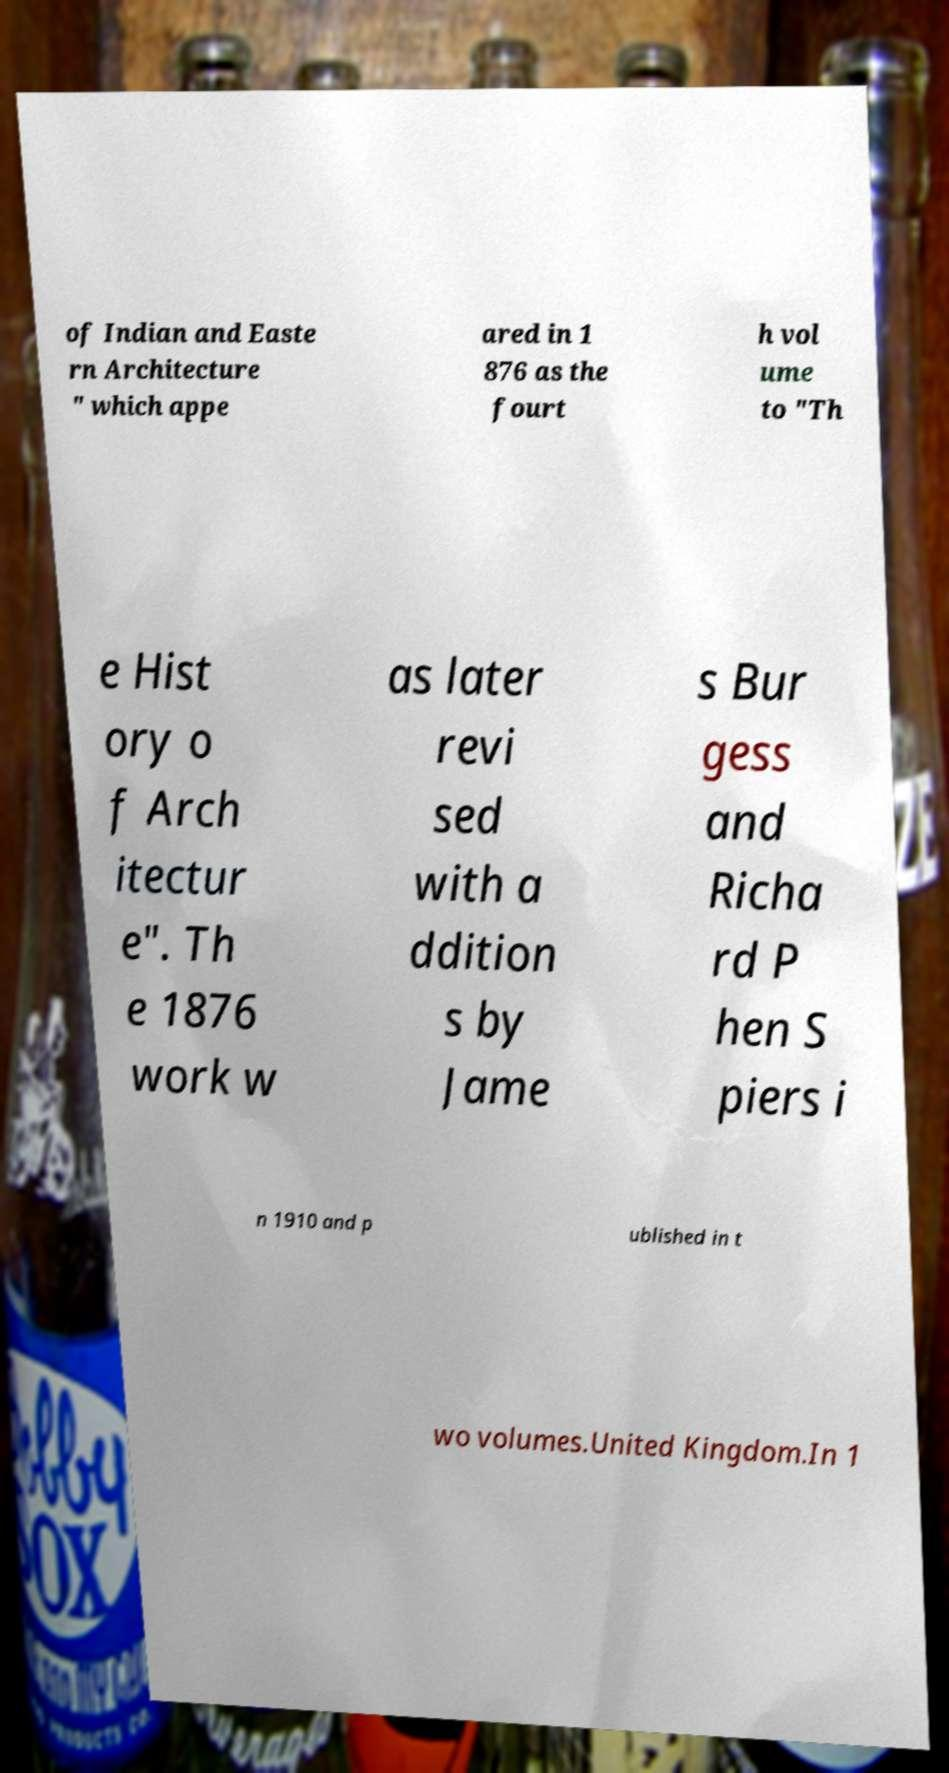Please identify and transcribe the text found in this image. of Indian and Easte rn Architecture " which appe ared in 1 876 as the fourt h vol ume to "Th e Hist ory o f Arch itectur e". Th e 1876 work w as later revi sed with a ddition s by Jame s Bur gess and Richa rd P hen S piers i n 1910 and p ublished in t wo volumes.United Kingdom.In 1 